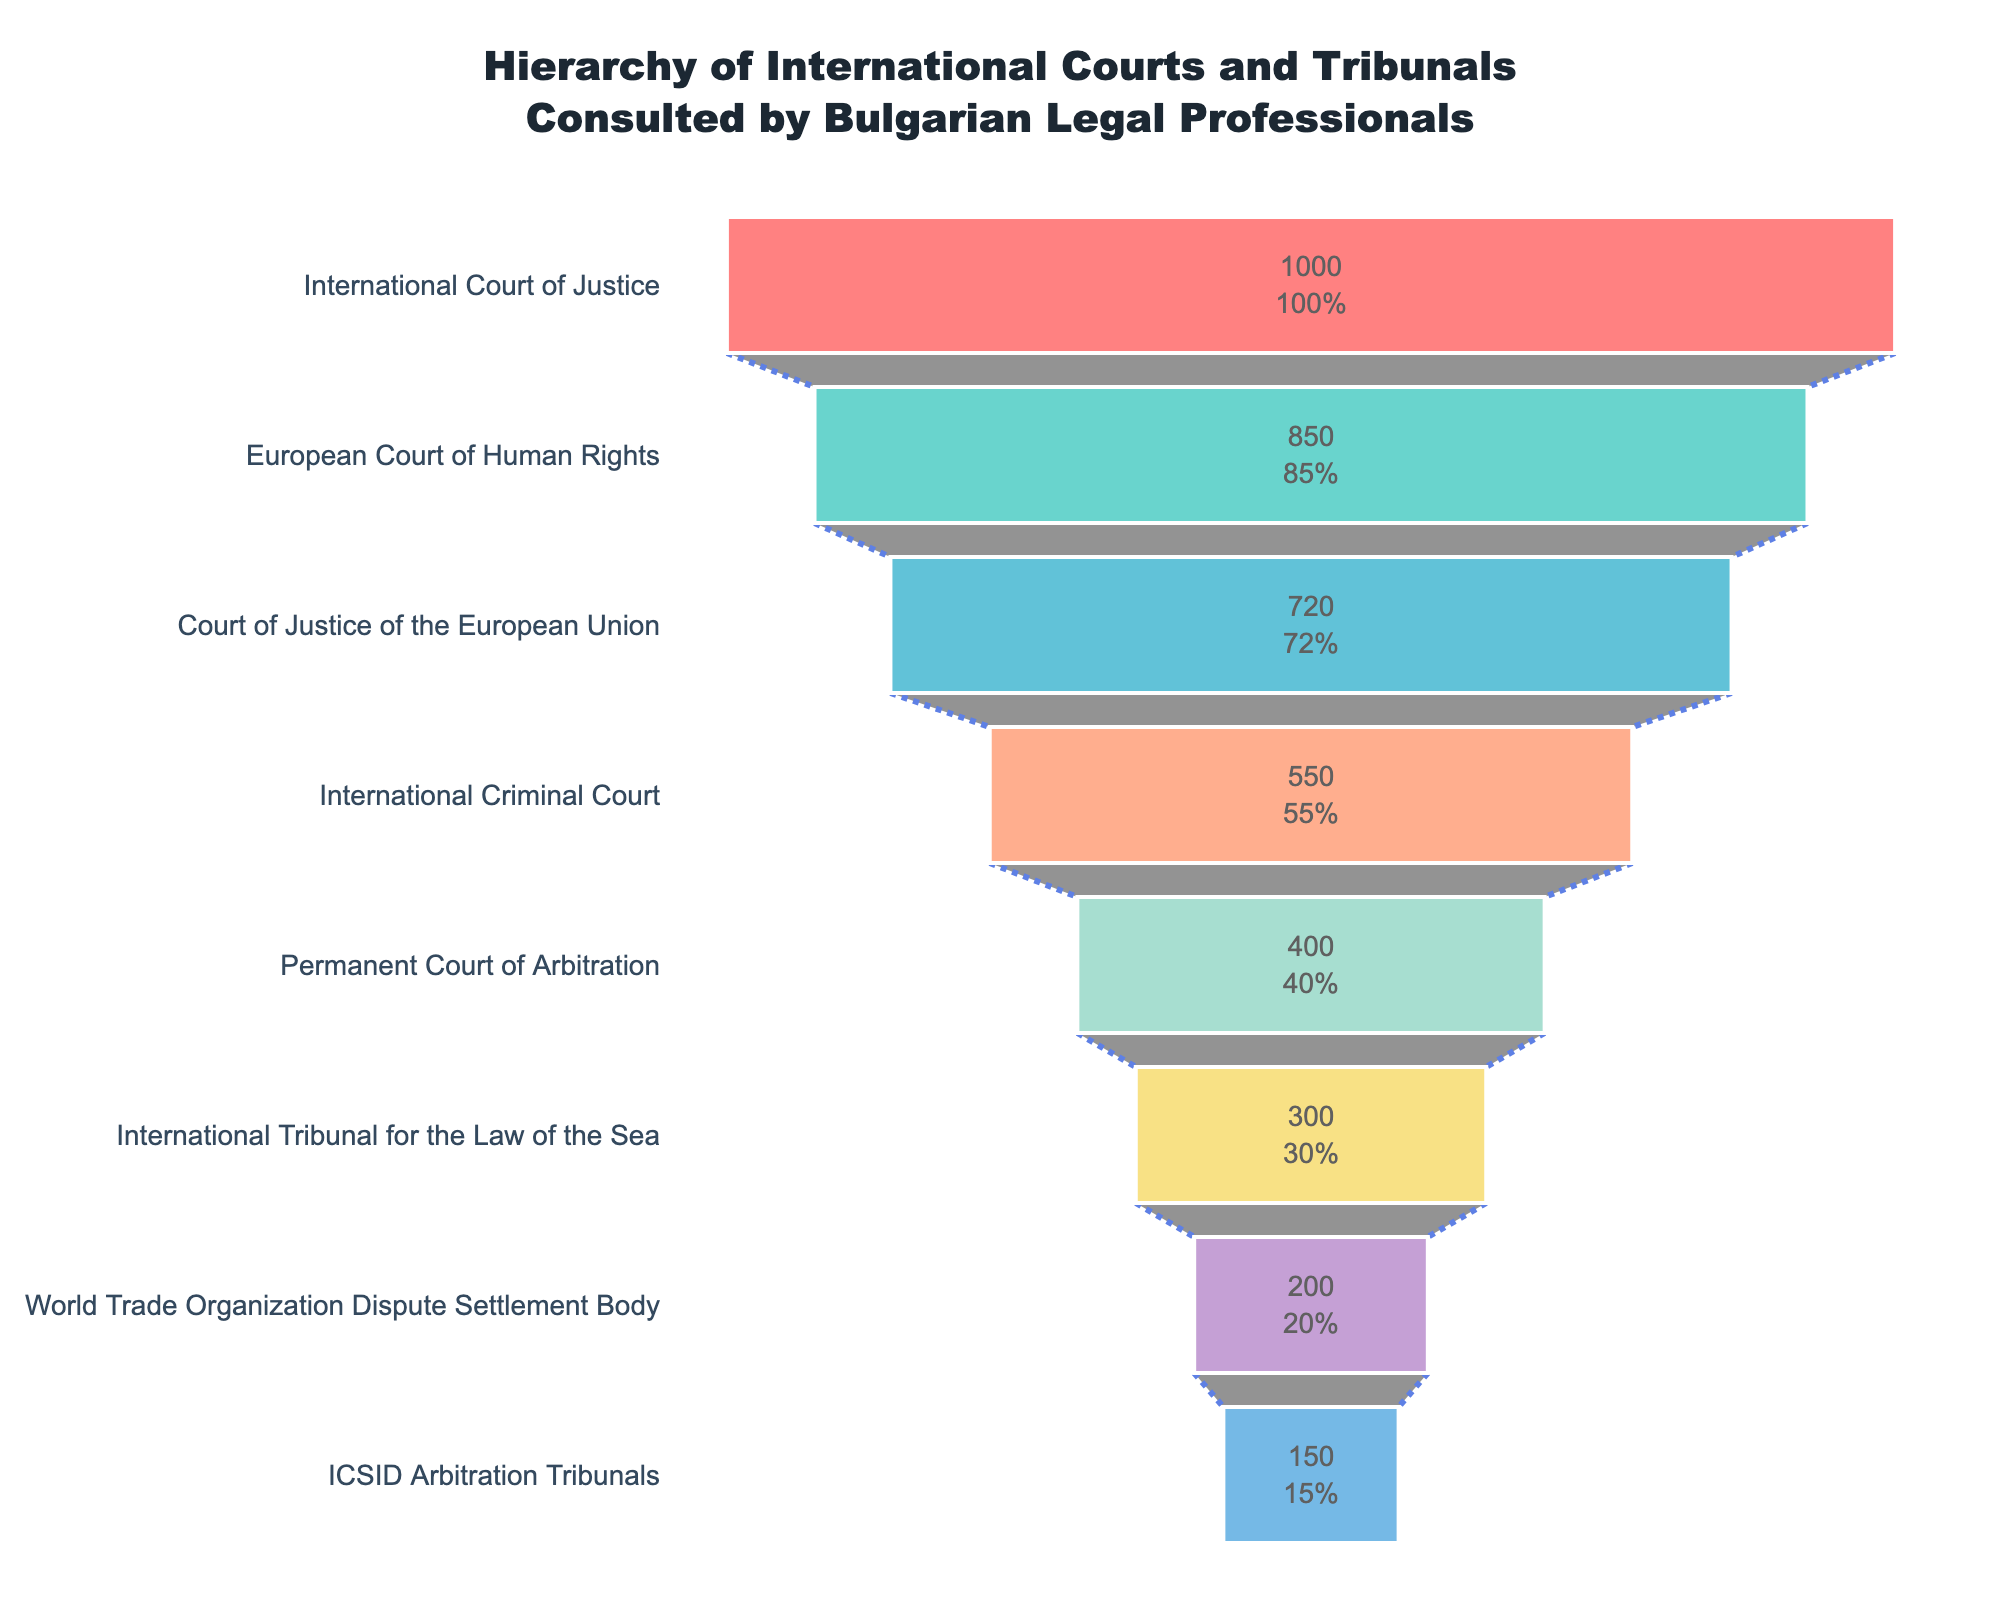What court or tribunal has the highest number of consultations? The figure shows a funnel chart, where the top position indicates the highest number of consultations. The International Court of Justice is at the top with 1000 consultations.
Answer: International Court of Justice What percentage of the total consultations is accounted for by the European Court of Human Rights? First, check the value for the European Court of Human Rights in the chart (850). Then, sum the consultations for all courts: 1000 + 850 + 720 + 550 + 400 + 300 + 200 + 150 = 4170. Finally, calculate (850 / 4170) * 100.
Answer: 20.38% How many more consultations does the International Court of Justice have compared to the International Criminal Court? The chart shows the International Court of Justice with 1000 consultations and the International Criminal Court with 550 consultations. Subtract 550 from 1000 to get the difference.
Answer: 450 Which court or tribunal ranks third in the number of consultations? The funnel chart ordered by consultation frequencies shows the Court of Justice of the European Union in the third position with 720 consultations.
Answer: Court of Justice of the European Union What is the combined number of consultations for the International Tribunal for the Law of the Sea and the World Trade Organization Dispute Settlement Body? The chart shows 300 consultations for the International Tribunal for the Law of the Sea and 200 for the World Trade Organization Dispute Settlement Body. Summing them gives 300 + 200.
Answer: 500 By how much does the number of consultations drop from the European Court of Human Rights to the Court of Justice of the European Union? The chart shows that the European Court of Human Rights has 850 consultations, and the Court of Justice of the European Union has 720 consultations. Calculate the difference: 850 - 720.
Answer: 130 Is the number of consultations for the Permanent Court of Arbitration greater than the combined consultations for the ICSID Arbitration Tribunals and the World Trade Organization Dispute Settlement Body? First, check the consultations: Permanent Court of Arbitration has 400, ICSID Arbitration Tribunals have 150, and the World Trade Organization Dispute Settlement Body has 200. The combined consultations for ICSID and WTO is 150 + 200 = 350. Since 400 is greater than 350, the answer is yes.
Answer: Yes What percentage of the total consultations does the International Court of Justice account for? First, check the value for the International Court of Justice (1000) and then sum up all the consultations (4170). Calculate (1000 / 4170) * 100.
Answer: 23.98% Which court or tribunal is consulted half as frequently as the European Court of Human Rights? The European Court of Human Rights has 850 consultations. Half of 850 is 425. The closest tribunal by the number of consultations is the Permanent Court of Arbitration with 400 consultations, which fits the "half as frequently" condition.
Answer: Permanent Court of Arbitration 